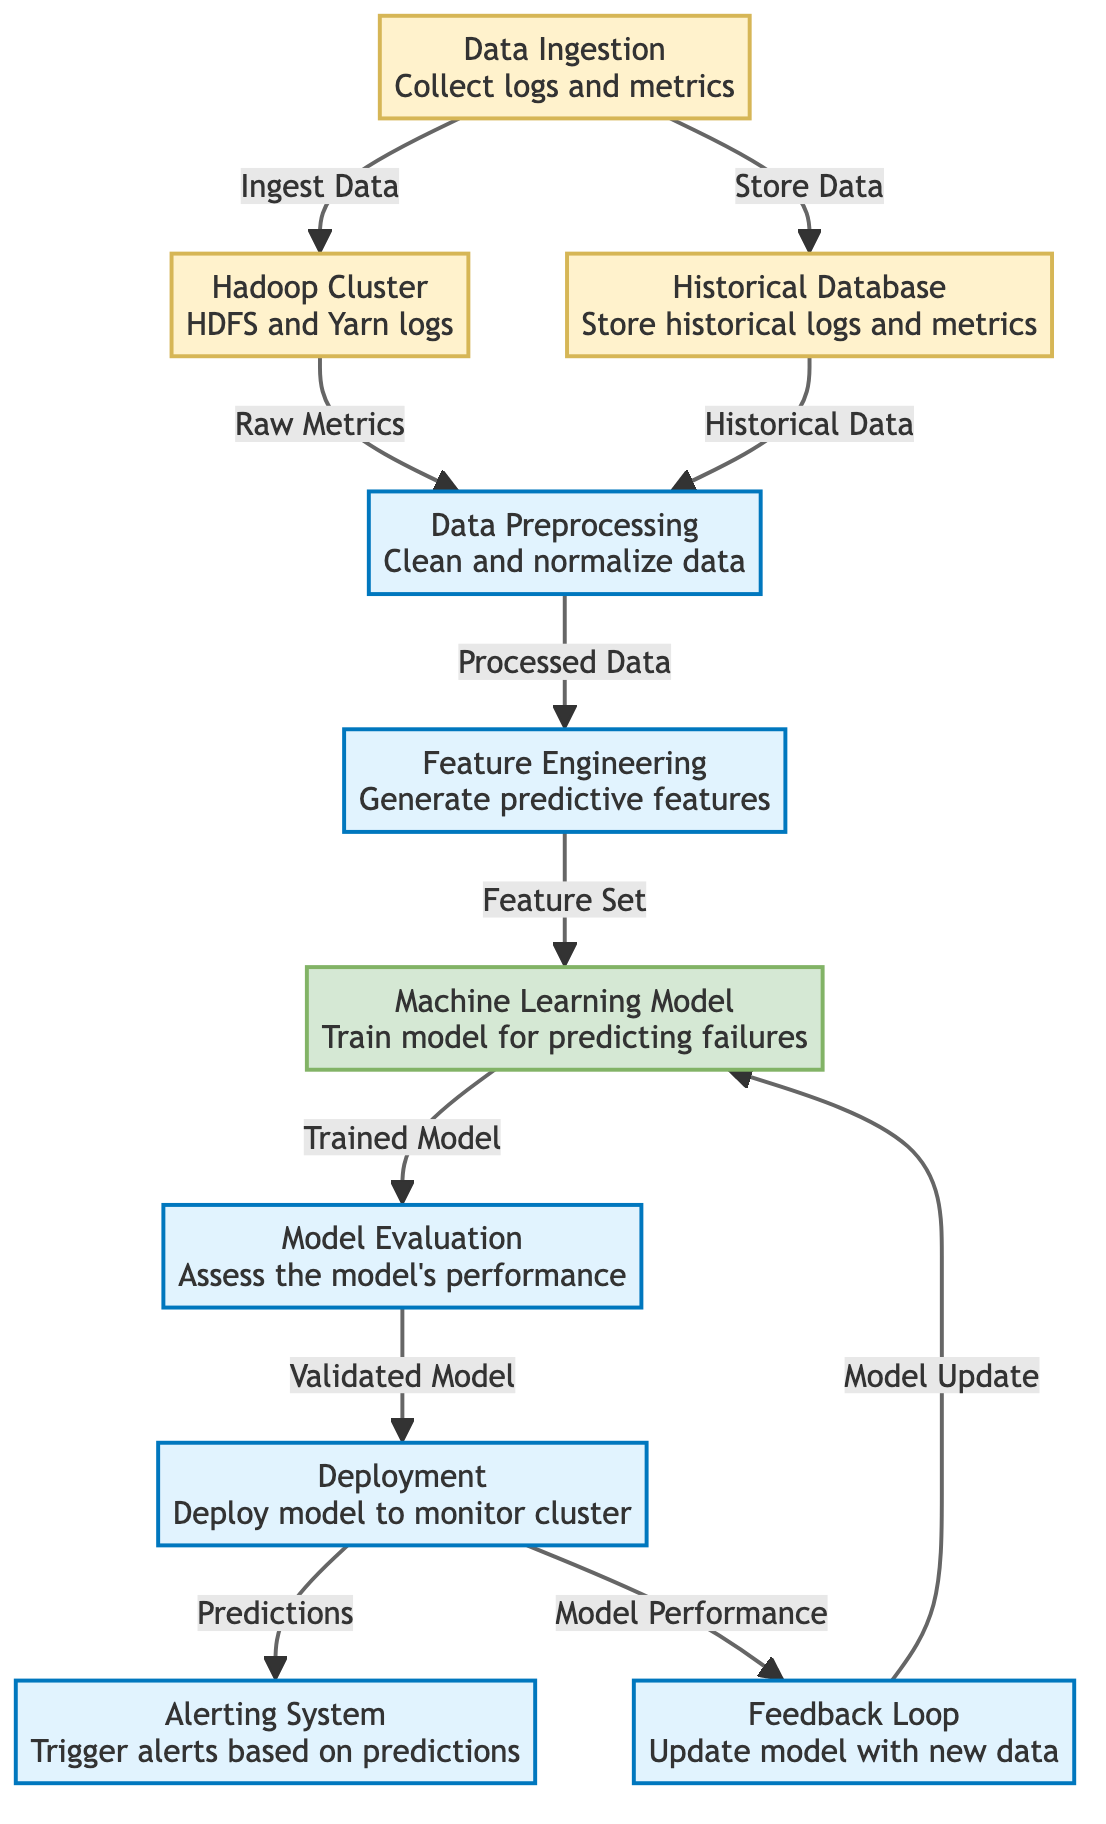What is the first step in the diagram? The first step in the diagram is "Data Ingestion," where logs and metrics are collected.
Answer: Data Ingestion How many nodes are present in the diagram? There are ten nodes in the diagram, each representing different steps in the predictive maintenance process.
Answer: Ten What type of data is collected during Data Ingestion? During Data Ingestion, logs and metrics from the Hadoop Cluster are collected.
Answer: Logs and metrics What does the ML Model output? The output of the ML Model is a trained model that is used for predicting hardware failures.
Answer: Trained Model Which node follows Model Evaluation? The node that follows Model Evaluation is Deployment, where the model is deployed to monitor the cluster.
Answer: Deployment What do we call the process of generating predictive features? The process of generating predictive features is called Feature Engineering.
Answer: Feature Engineering How is historical data accessed in the diagram? Historical data is accessed from the Database, which stores historical logs and metrics.
Answer: Database What is the purpose of the Feedback Loop? The purpose of the Feedback Loop is to update the model with new data to improve predictions.
Answer: Model Update Which node triggers alerts based on predictions? The node that triggers alerts based on predictions is called the Alerting System.
Answer: Alerting System 